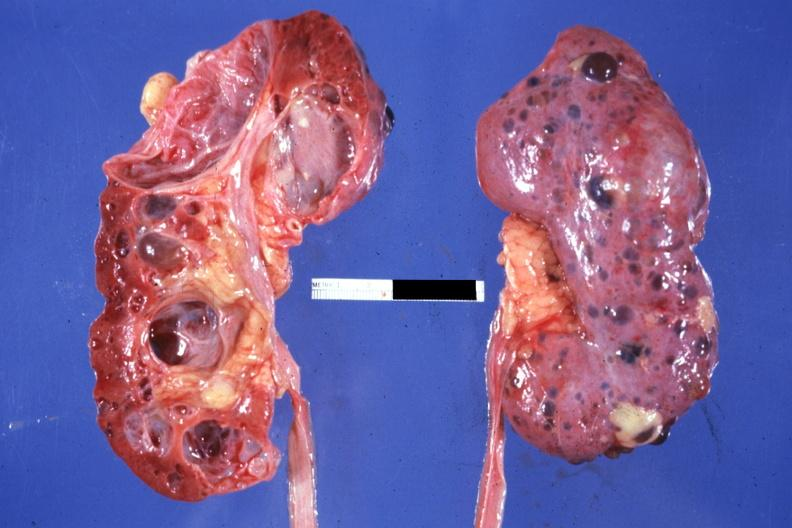s pharynx opened the other from capsular surface many cysts?
Answer the question using a single word or phrase. No 